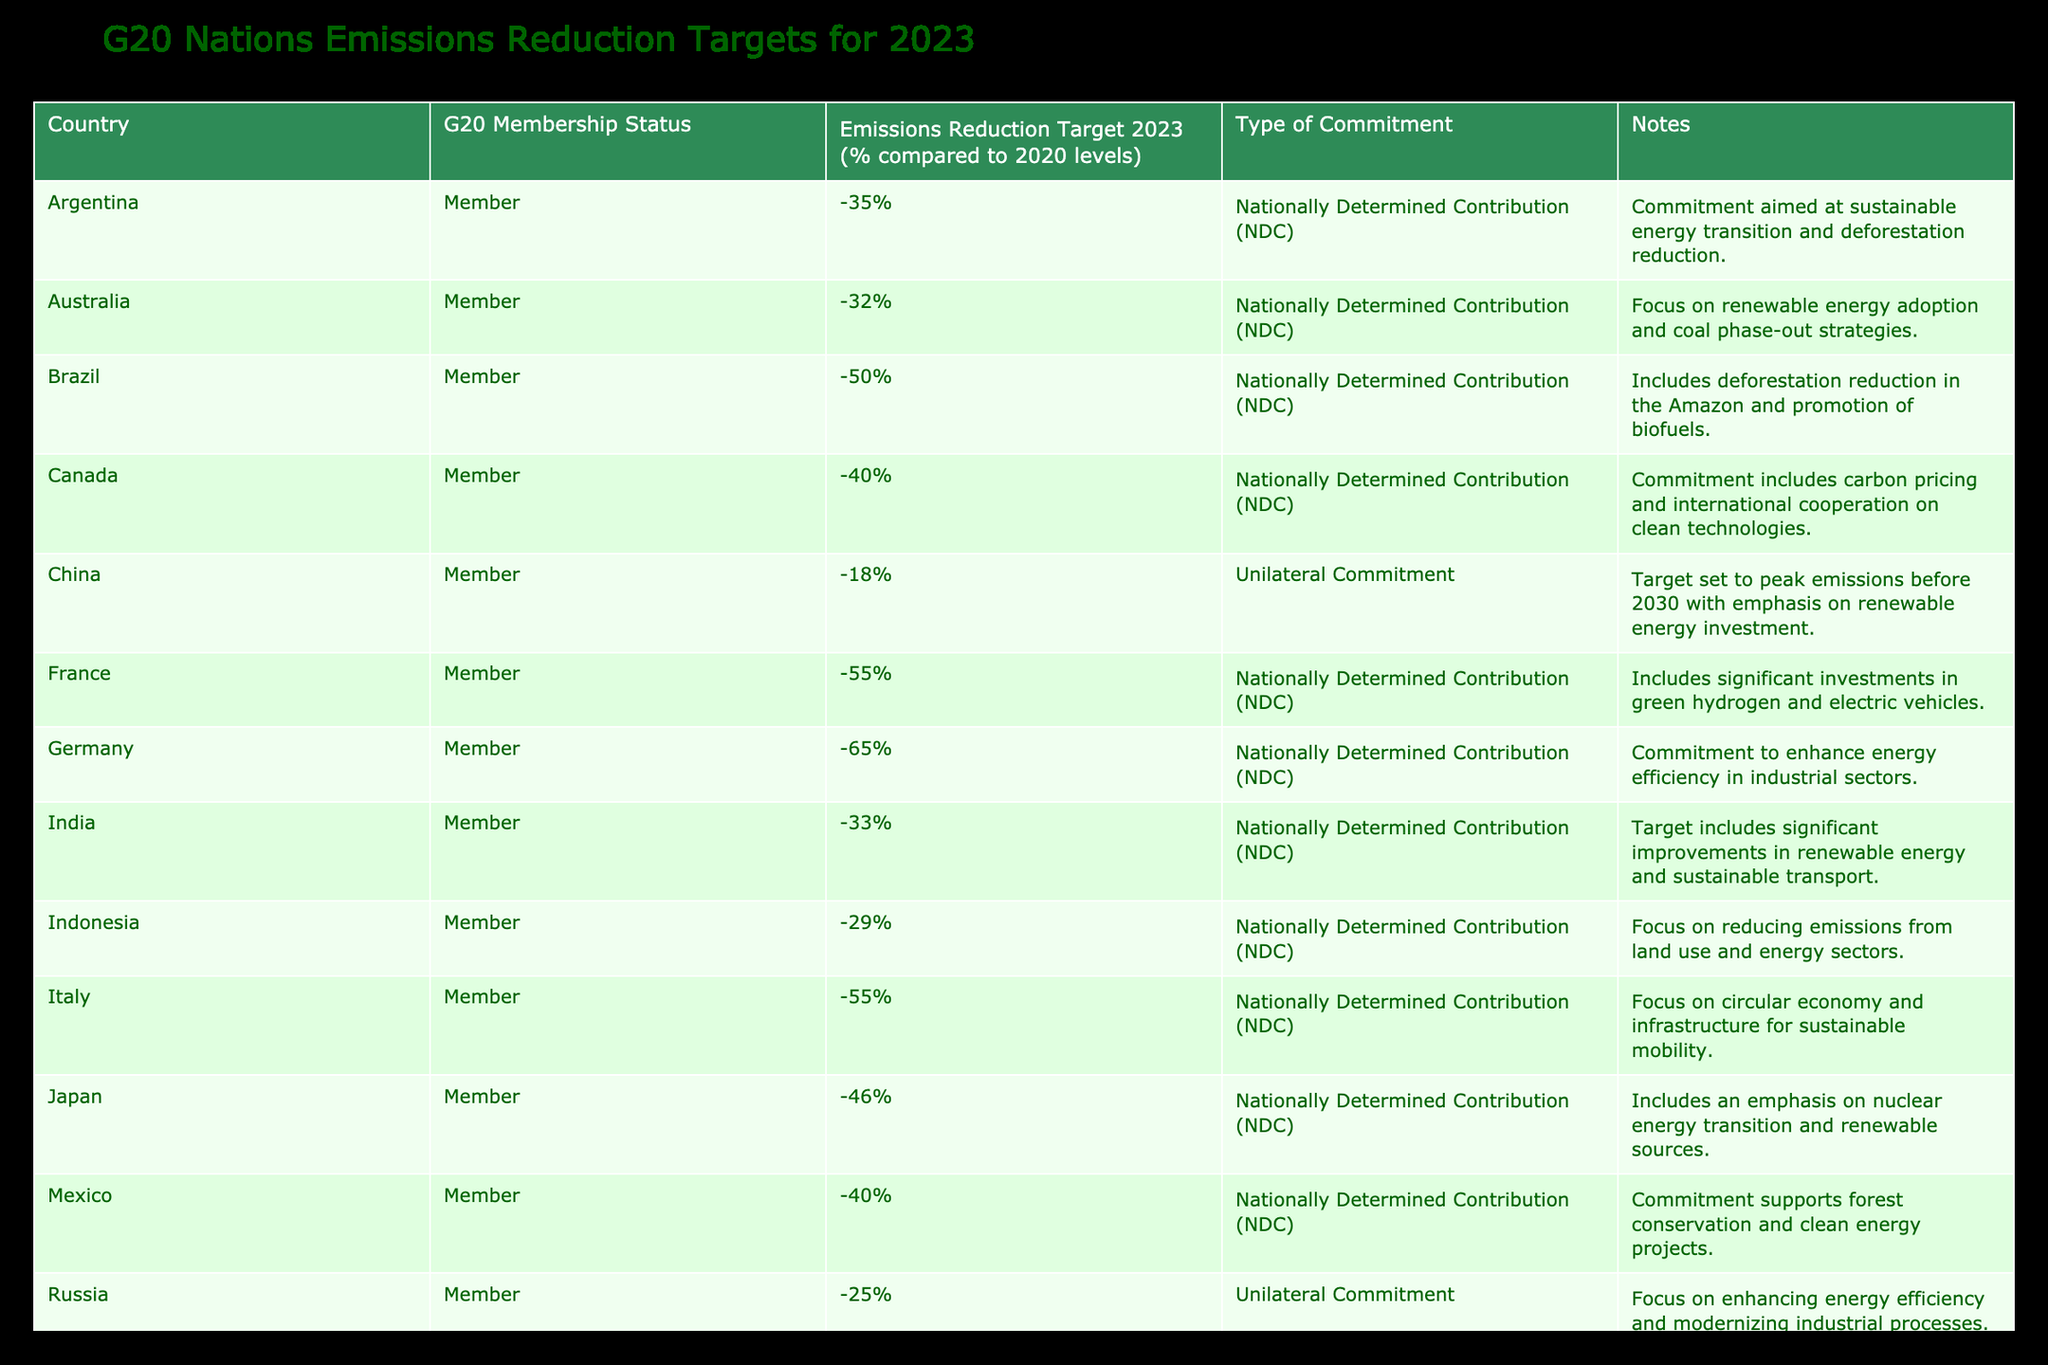What is the highest emissions reduction target among G20 nations for 2023? Looking at the table, Germany has the highest emissions reduction target at -65% compared to 2020 levels.
Answer: -65% Which country has the most ambitious emissions reduction target focused on deforestation? Brazil, with a target of -50%, includes a substantial emphasis on reducing deforestation in the Amazon.
Answer: Brazil How many G20 nations have set emissions reduction targets of 40% or greater? By examining the targets, there are five countries (Canada, France, Germany, Italy, and the UK) with targets at 40% or higher, totaling five nations.
Answer: 5 Is India committed to reducing emissions by more than 30% in 2023? India has set a target of -33%, which exceeds a 30% reduction, indicating the commitment is indeed more than 30%.
Answer: Yes Which countries have unilateral commitments rather than NDCs, and what are their targets? The countries with unilateral commitments are China (-18%) and Russia (-25%). There are no other countries listed with unilateral commitments in the table.
Answer: China (-18%), Russia (-25%) What is the average emissions reduction target percentage of G20 nations for 2023? To find the average, sum the reduction targets and divide by the number of countries. Adding all targets: -35 -32 -50 -40 -18 -55 -65 -33 -29 -55 -46 -40 -25 -30 -34 -40 -21 -68 -50 = -788. Since there are 19 nations, the average is -788 / 19 = approximately -41.47%.
Answer: -41.47% Which G20 country has the least aggressive emissions reduction target? By reviewing the table, China has the least aggressive target at -18% compared to 2020 levels.
Answer: China Is there a country in the G20 with a target that exceeds -60%? Yes, Germany and the United Kingdom both have targets exceeding -60%, with Germany at -65% and the UK at -68%.
Answer: Yes List the G20 countries that emphasize renewable energy in their commitments. The countries emphasizing renewable energy in their commitments include Australia, China, Germany, India, South Africa, Japan, and South Korea, indicating a significant emphasis on renewable sources in multiple targets.
Answer: Australia, China, Germany, India, South Africa, Japan, South Korea 